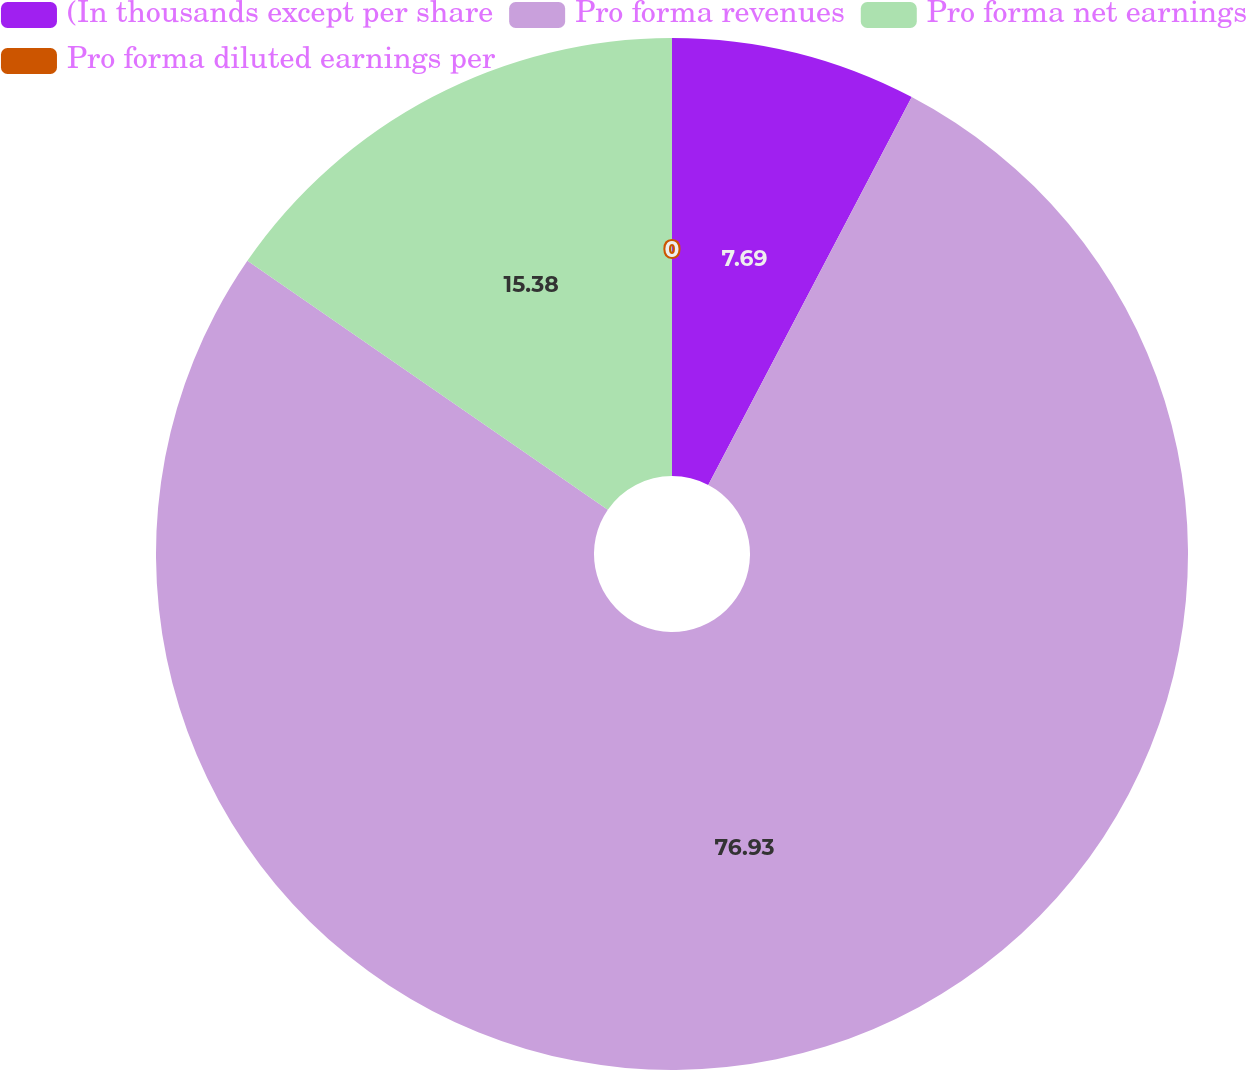<chart> <loc_0><loc_0><loc_500><loc_500><pie_chart><fcel>(In thousands except per share<fcel>Pro forma revenues<fcel>Pro forma net earnings<fcel>Pro forma diluted earnings per<nl><fcel>7.69%<fcel>76.92%<fcel>15.38%<fcel>0.0%<nl></chart> 